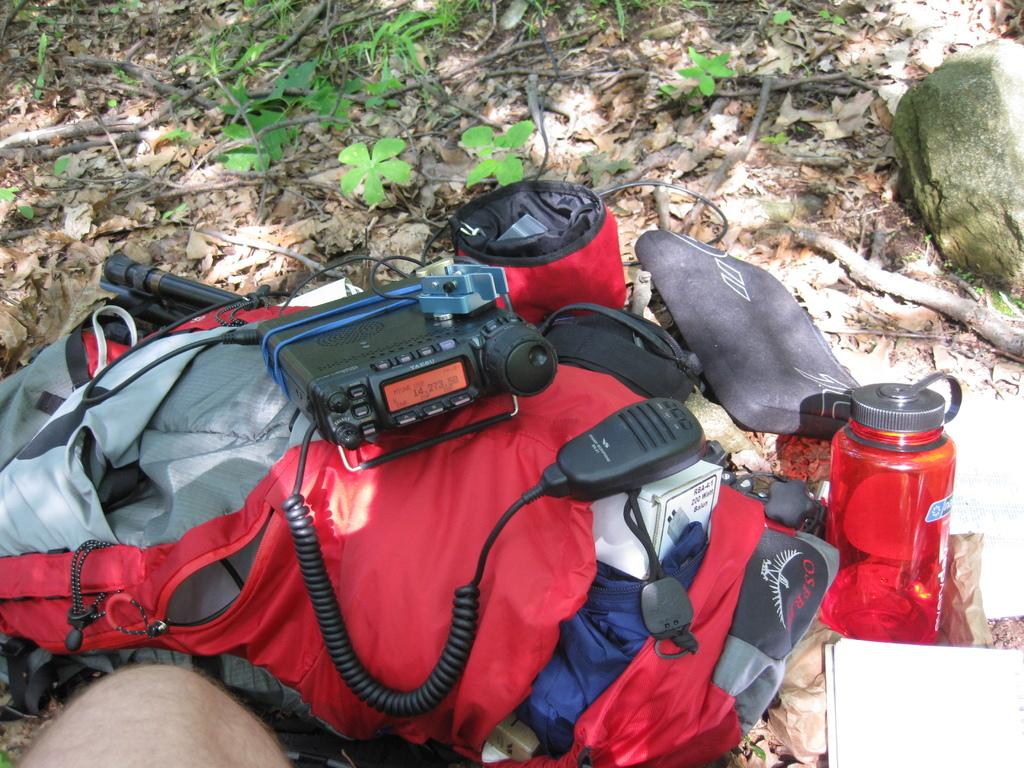What type of items can be seen in the image? There are bags, a bottle, other objects, papers, and a rock in the image. Can you describe the person in the image? There is a person in the image, but no specific details about their appearance or actions are provided. What is visible in the background of the image? Leaves are present on the ground in the background of the image. What type of oil is being used on the stove in the image? There is no stove or oil present in the image; it features bags, a bottle, other objects, papers, a person, a rock, and leaves on the ground in the background. Can you tell me how many kittens are visible in the image? There are no kittens present in the image. 